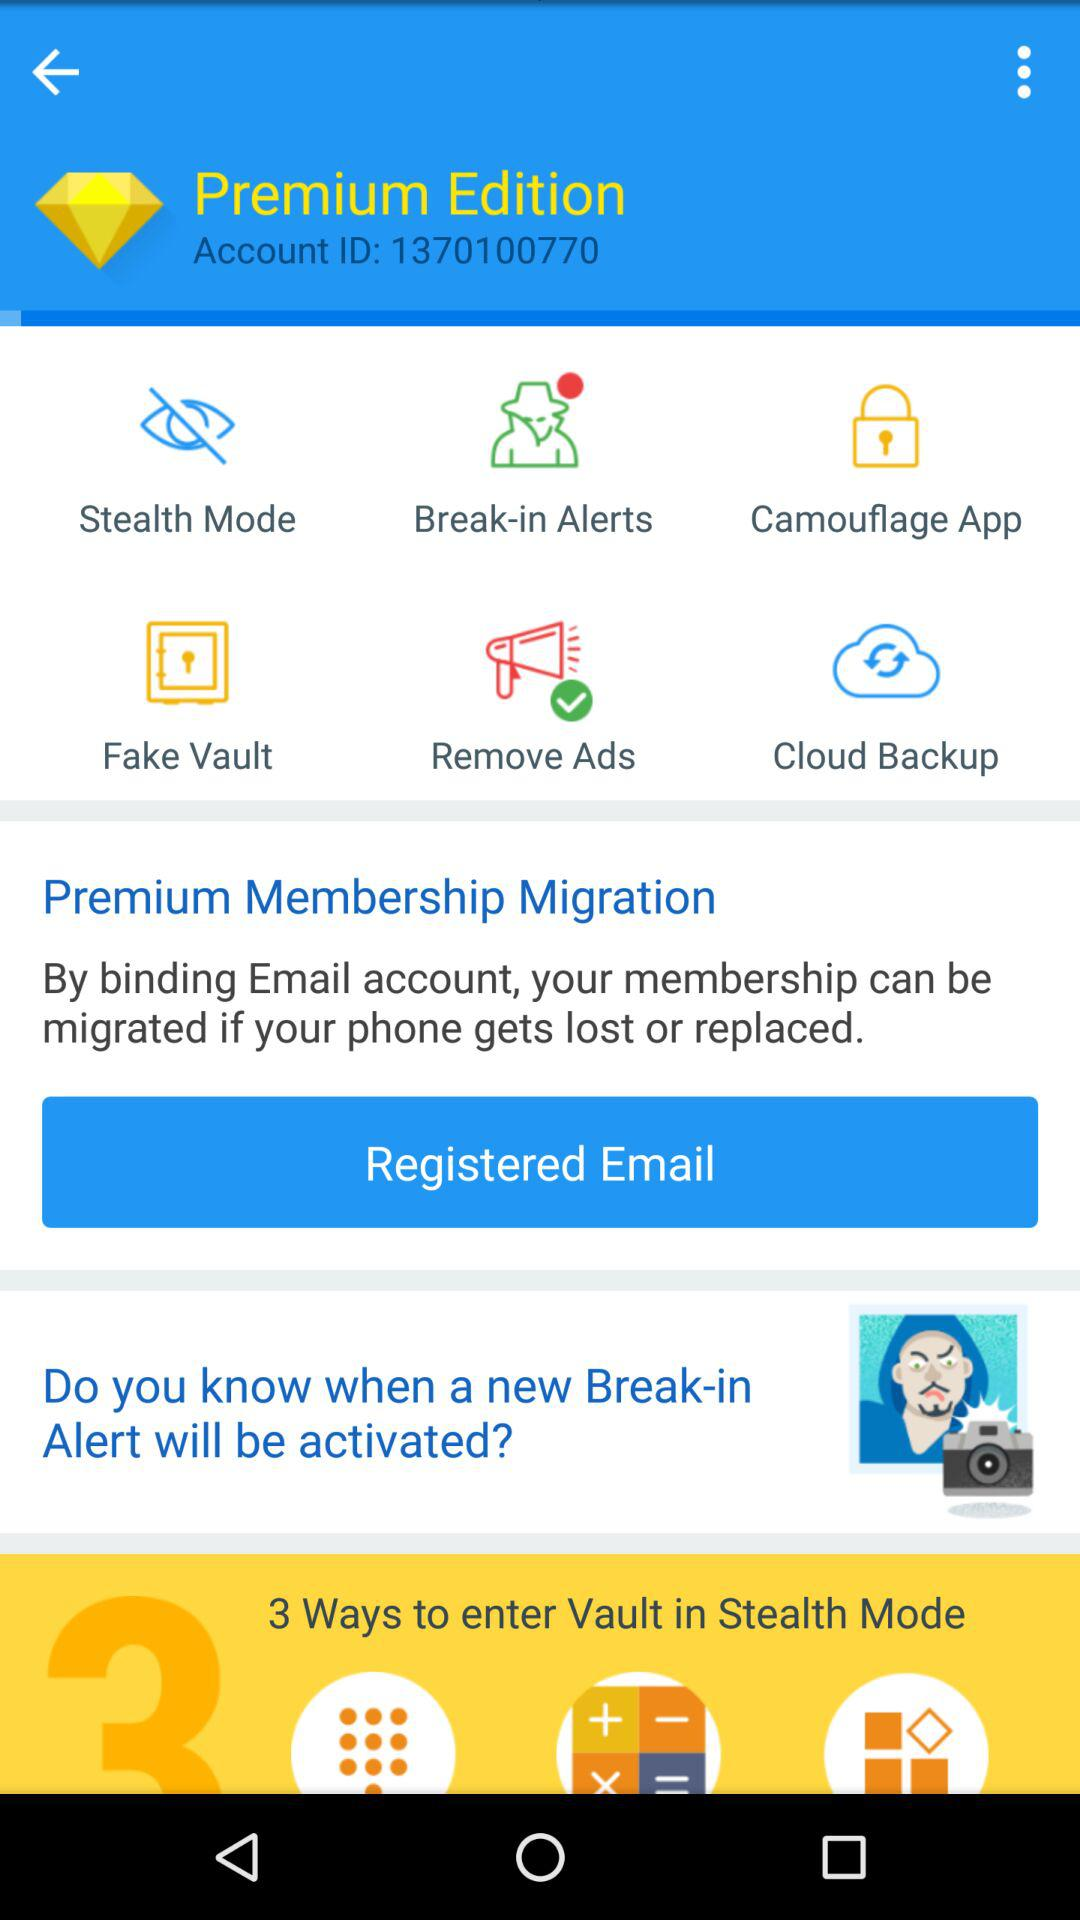How many break-in alerts are there?
When the provided information is insufficient, respond with <no answer>. <no answer> 